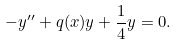<formula> <loc_0><loc_0><loc_500><loc_500>- y ^ { \prime \prime } + q ( x ) y + \frac { 1 } { 4 } y = 0 .</formula> 